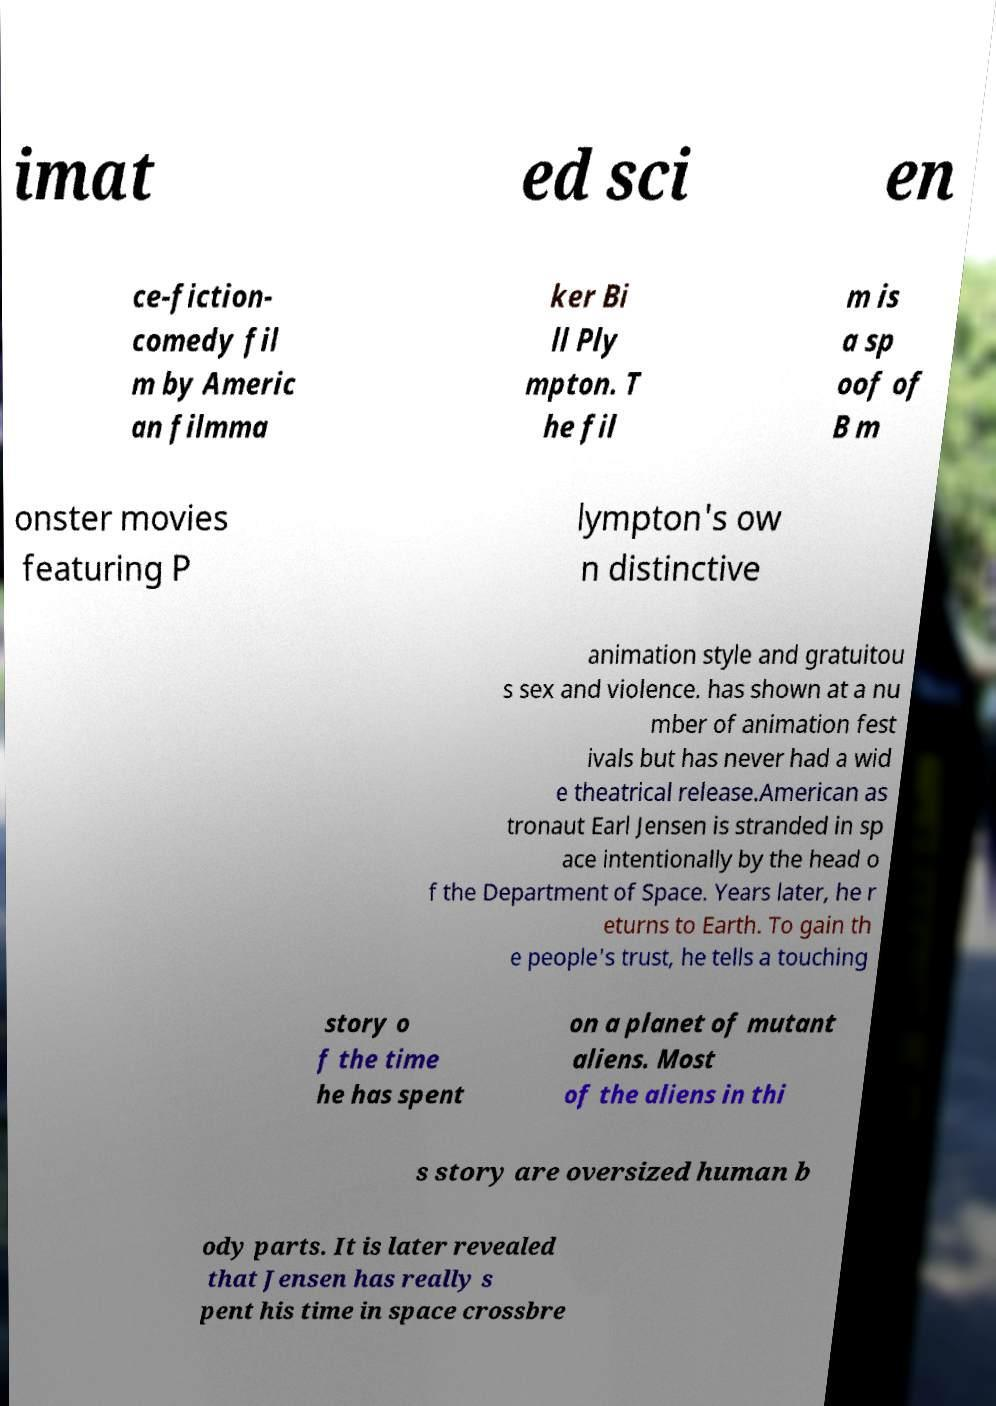There's text embedded in this image that I need extracted. Can you transcribe it verbatim? imat ed sci en ce-fiction- comedy fil m by Americ an filmma ker Bi ll Ply mpton. T he fil m is a sp oof of B m onster movies featuring P lympton's ow n distinctive animation style and gratuitou s sex and violence. has shown at a nu mber of animation fest ivals but has never had a wid e theatrical release.American as tronaut Earl Jensen is stranded in sp ace intentionally by the head o f the Department of Space. Years later, he r eturns to Earth. To gain th e people's trust, he tells a touching story o f the time he has spent on a planet of mutant aliens. Most of the aliens in thi s story are oversized human b ody parts. It is later revealed that Jensen has really s pent his time in space crossbre 